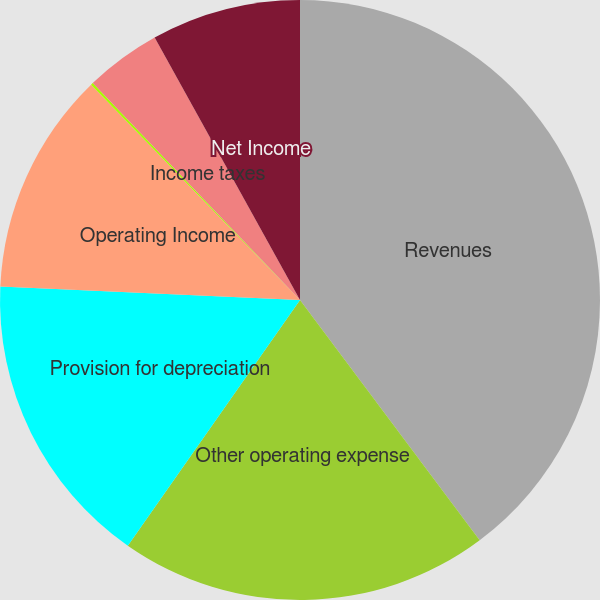Convert chart to OTSL. <chart><loc_0><loc_0><loc_500><loc_500><pie_chart><fcel>Revenues<fcel>Other operating expense<fcel>Provision for depreciation<fcel>Operating Income<fcel>Income before income taxes<fcel>Income taxes<fcel>Net Income<nl><fcel>39.78%<fcel>19.95%<fcel>15.99%<fcel>12.02%<fcel>0.12%<fcel>4.09%<fcel>8.05%<nl></chart> 